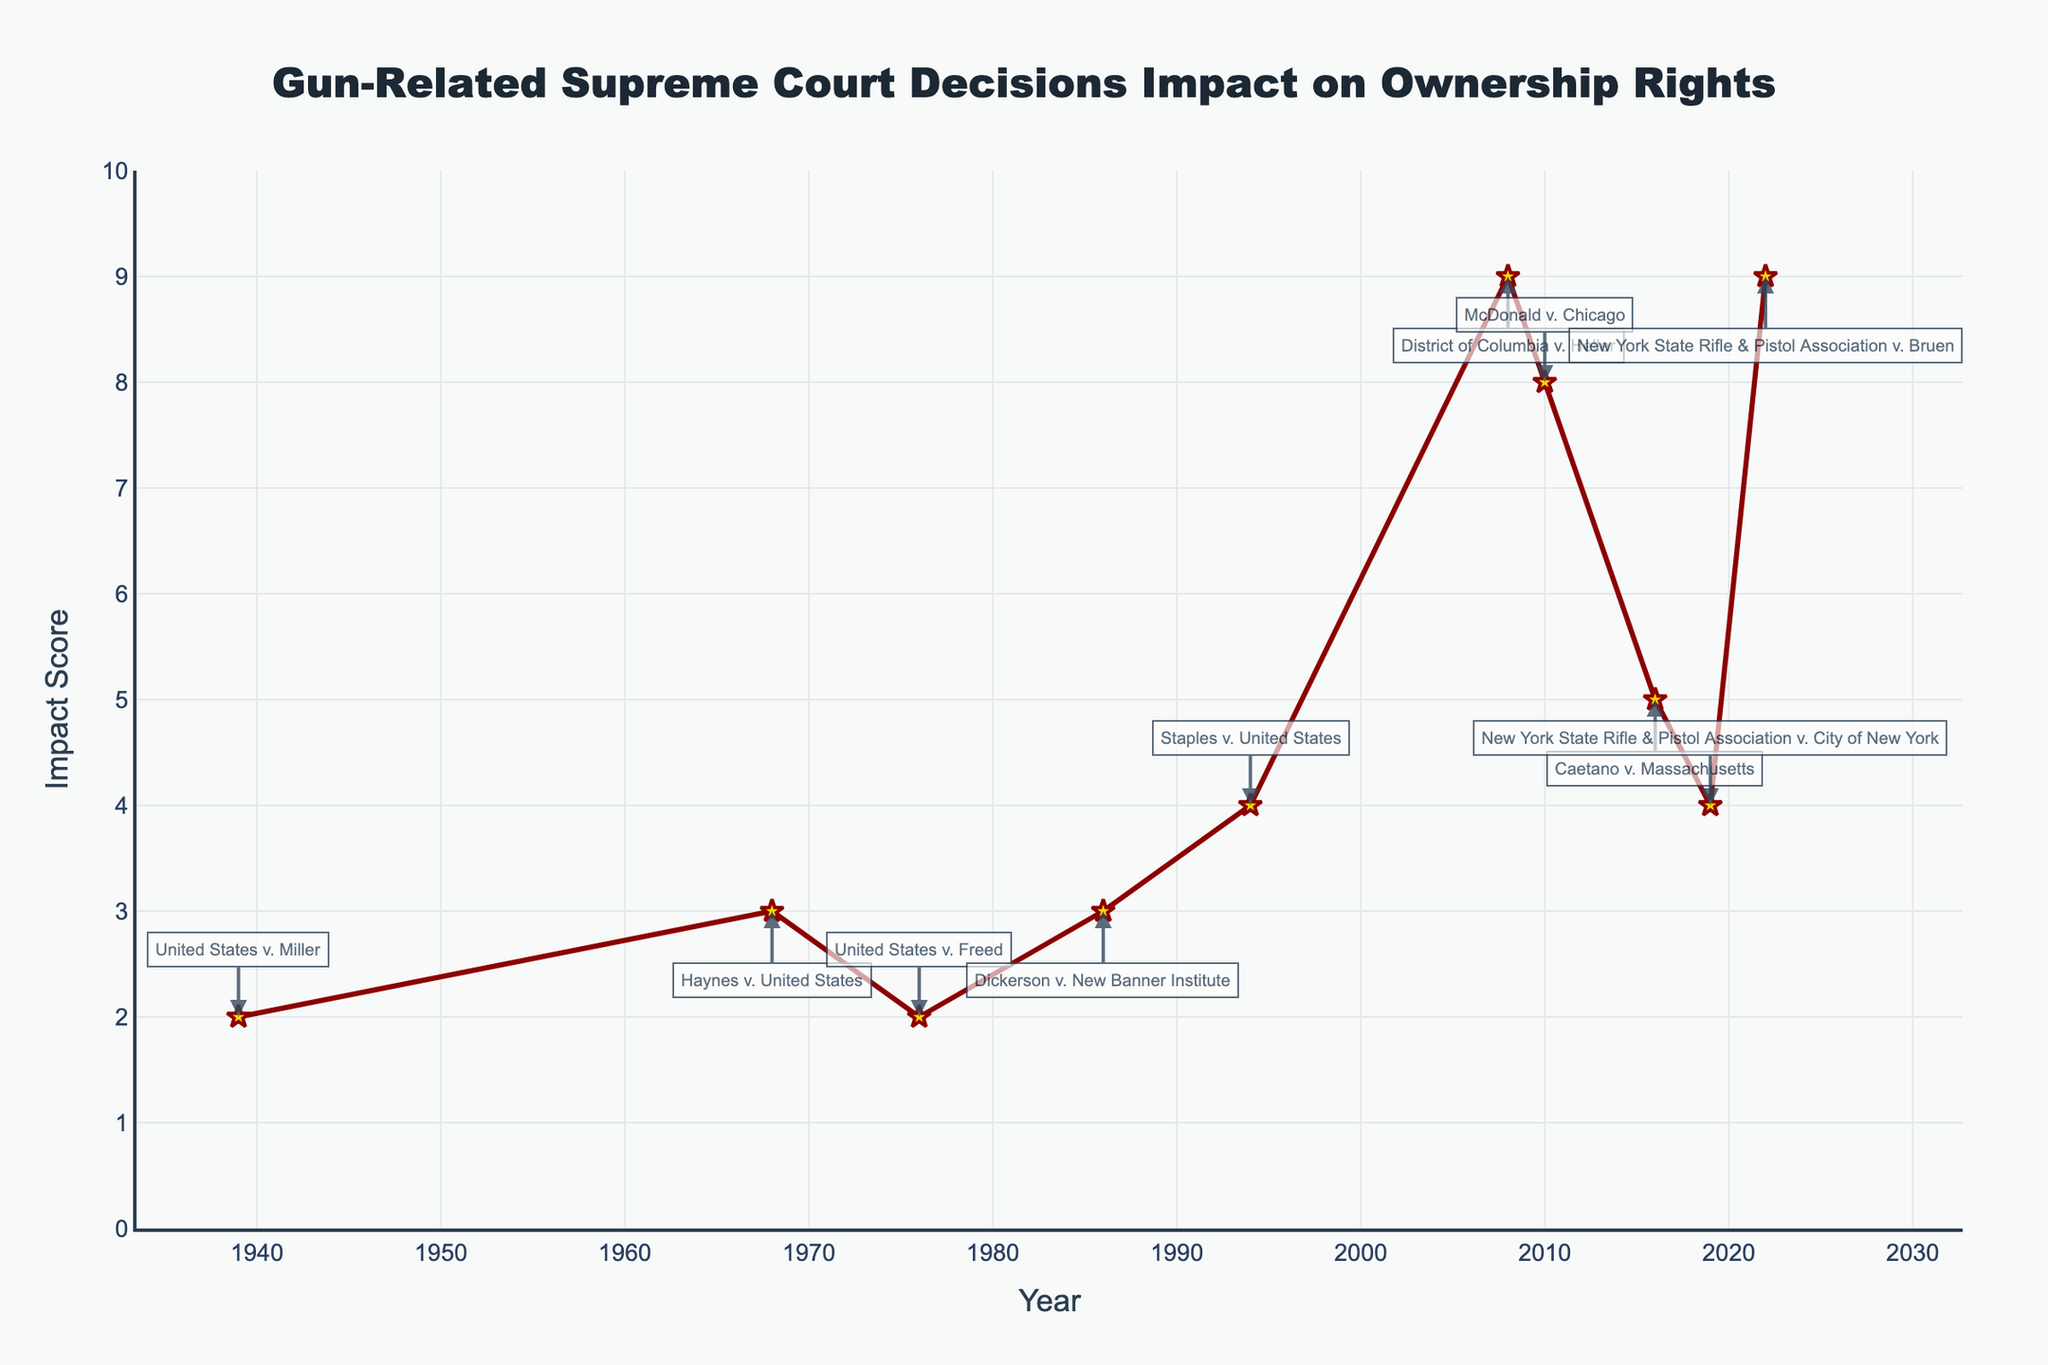What's the average Impact Score for cases between 2000 and 2022? To find the average Impact Score for cases between 2000 and 2022, identify the relevant cases: District of Columbia v. Heller (2008), McDonald v. Chicago (2010), Caetano v. Massachusetts (2016), New York State Rifle & Pistol Association v. City of New York (2019), and New York State Rifle & Pistol Association v. Bruen (2022). Their impact scores are 9, 8, 5, 4, and 9, respectively. Sum them up: 9+8+5+4+9=35. There are 5 cases, so the average is 35/5 = 7.
Answer: 7 Which case has the highest Impact Score? Look at the visual attributes of the line chart to identify which point reaches the highest on the y-axis. The cases District of Columbia v. Heller (2008) and New York State Rifle & Pistol Association v. Bruen (2022) both have the highest Impact Score.
Answer: District of Columbia v. Heller (2008), New York State Rifle & Pistol Association v. Bruen (2022) Which year witnessed the maximum increase in Impact Score from the previous case? Compare the differences in Impact Scores between consecutive cases. Highest difference appears between Staples v. United States (1994) with a score of 4 and District of Columbia v. Heller (2008) with a score of 9, making the increase 9-4=5 between 1994 and 2008, which is the maximum increase.
Answer: 2008 What is the difference in Impact Scores between Haynes v. United States (1968) and United States v. Freed (1976)? Identify the Impact Scores from the chart for both cases: Haynes v. United States (1968) has an impact score of 3, and United States v. Freed (1976) has a score of 2. The difference is 3-2=1.
Answer: 1 During which time period do the most significant changes in Impact Scores occur? Observe the changes in the Impact Scores over different periods. A significant change is noted between 2000-2022, with notable high values especially in 2008 (9), 2010 (8), and 2022 (9).
Answer: 2000-2022 How many cases have an Impact Score of at least 5? Count the cases where the impact score is 5 or greater. These cases are District of Columbia v. Heller (2008) with 9, McDonald v. Chicago (2010) with 8, Caetano v. Massachusetts (2016) with 5, and New York State Rifle & Pistol Association v. Bruen (2022) with 9. There are 4 such cases.
Answer: 4 Which case(s) have the same Impact Scores? Identify cases with equal scores by looking at the y-axis values. United States v. Miller (1939) and United States v. Freed (1976) both have a score of 2. Also, Haynes v. United States (1968) and Dickerson v. New Banner Institute (1986) both have a score of 3.
Answer: United States v. Miller (1939), United States v. Freed (1976); Haynes v. United States (1968), Dickerson v. New Banner Institute (1986) How does the Impact Score trend change before and after the year 2000? Review the visual trend of the Impact Scores relative to the year 2000. Before 2000, the scores are generally lower with the highest being 4 in 1994. After 2000, there is a noticeable increase with scores reaching up to 9.
Answer: Increases after 2000 What is the Impact Score range for the cases depicted? Identify the minimum and maximum Impact Scores from the line chart. The minimum Impact Score is 2, and the maximum is 9.
Answer: 2-9 